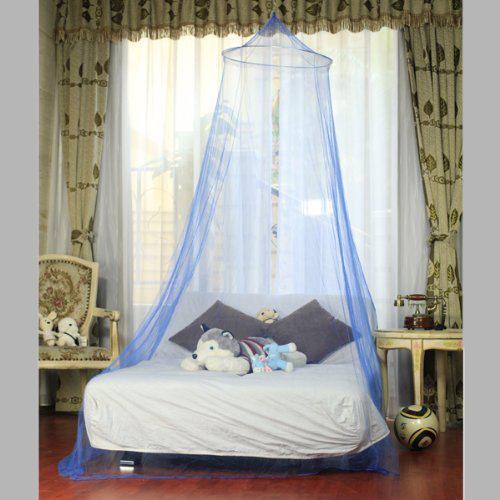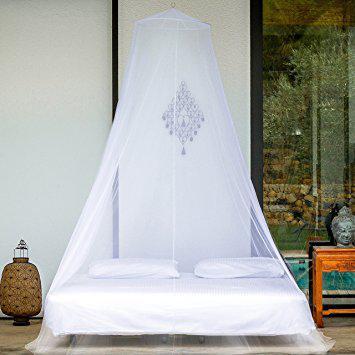The first image is the image on the left, the second image is the image on the right. For the images shown, is this caption "One of the beds has a wooden frame." true? Answer yes or no. No. 